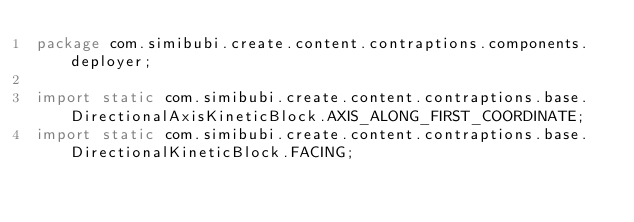<code> <loc_0><loc_0><loc_500><loc_500><_Java_>package com.simibubi.create.content.contraptions.components.deployer;

import static com.simibubi.create.content.contraptions.base.DirectionalAxisKineticBlock.AXIS_ALONG_FIRST_COORDINATE;
import static com.simibubi.create.content.contraptions.base.DirectionalKineticBlock.FACING;
</code> 